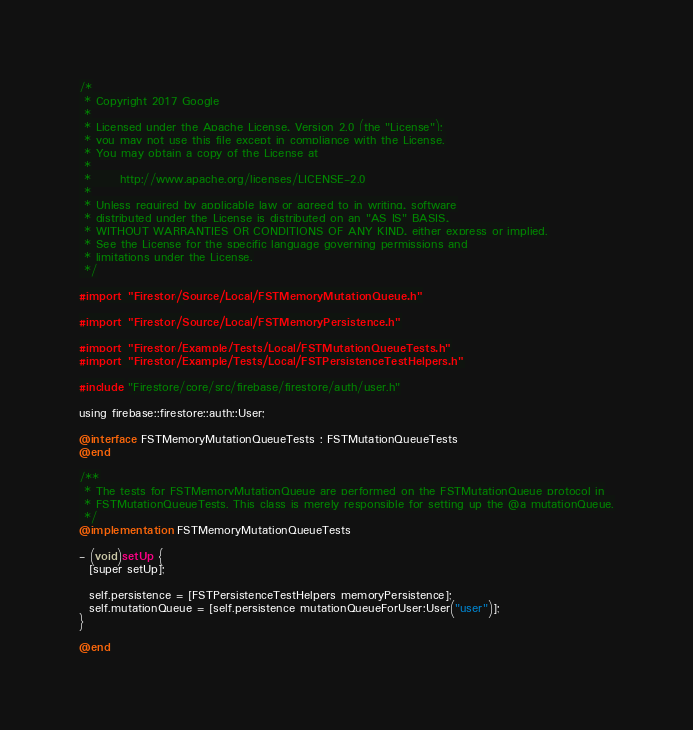Convert code to text. <code><loc_0><loc_0><loc_500><loc_500><_ObjectiveC_>/*
 * Copyright 2017 Google
 *
 * Licensed under the Apache License, Version 2.0 (the "License");
 * you may not use this file except in compliance with the License.
 * You may obtain a copy of the License at
 *
 *      http://www.apache.org/licenses/LICENSE-2.0
 *
 * Unless required by applicable law or agreed to in writing, software
 * distributed under the License is distributed on an "AS IS" BASIS,
 * WITHOUT WARRANTIES OR CONDITIONS OF ANY KIND, either express or implied.
 * See the License for the specific language governing permissions and
 * limitations under the License.
 */

#import "Firestore/Source/Local/FSTMemoryMutationQueue.h"

#import "Firestore/Source/Local/FSTMemoryPersistence.h"

#import "Firestore/Example/Tests/Local/FSTMutationQueueTests.h"
#import "Firestore/Example/Tests/Local/FSTPersistenceTestHelpers.h"

#include "Firestore/core/src/firebase/firestore/auth/user.h"

using firebase::firestore::auth::User;

@interface FSTMemoryMutationQueueTests : FSTMutationQueueTests
@end

/**
 * The tests for FSTMemoryMutationQueue are performed on the FSTMutationQueue protocol in
 * FSTMutationQueueTests. This class is merely responsible for setting up the @a mutationQueue.
 */
@implementation FSTMemoryMutationQueueTests

- (void)setUp {
  [super setUp];

  self.persistence = [FSTPersistenceTestHelpers memoryPersistence];
  self.mutationQueue = [self.persistence mutationQueueForUser:User("user")];
}

@end
</code> 